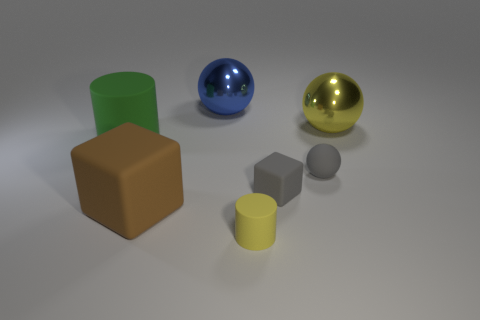Is there any other thing that is the same shape as the yellow metal thing?
Your answer should be very brief. Yes. How many spheres are either big blue things or tiny rubber things?
Your answer should be compact. 2. What number of large gray metallic spheres are there?
Ensure brevity in your answer.  0. What is the size of the yellow thing that is behind the object that is left of the brown rubber object?
Provide a short and direct response. Large. What number of other things are there of the same size as the yellow ball?
Your response must be concise. 3. What number of tiny matte cylinders are to the left of the large green thing?
Your response must be concise. 0. What size is the brown object?
Offer a very short reply. Large. Is the cylinder on the left side of the big brown matte object made of the same material as the block right of the big blue metal sphere?
Your answer should be compact. Yes. Are there any other rubber cubes that have the same color as the small rubber block?
Your answer should be compact. No. There is a ball that is the same size as the gray cube; what color is it?
Provide a succinct answer. Gray. 